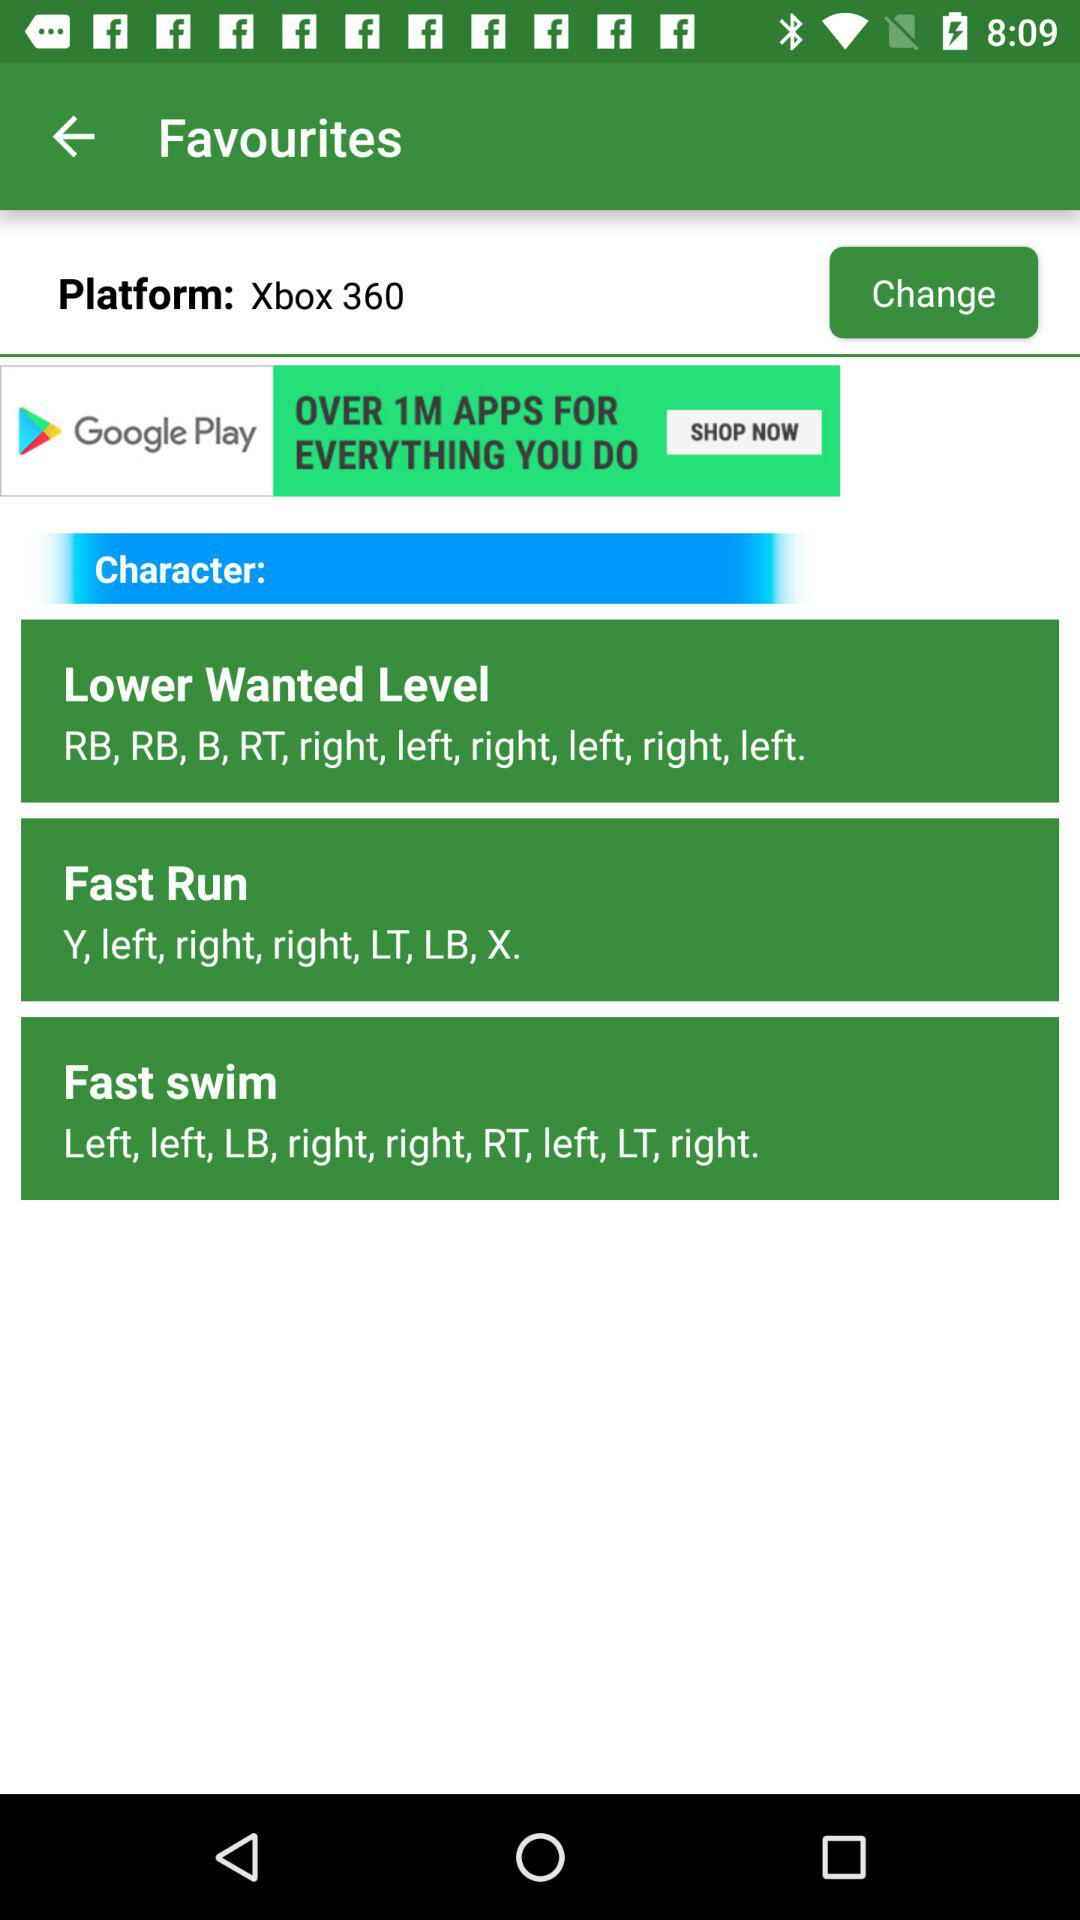How many characters are there?
When the provided information is insufficient, respond with <no answer>. <no answer> 